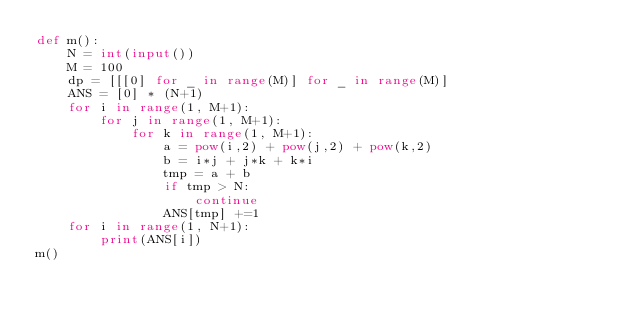Convert code to text. <code><loc_0><loc_0><loc_500><loc_500><_Python_>def m():
    N = int(input())
    M = 100
    dp = [[[0] for _ in range(M)] for _ in range(M)]
    ANS = [0] * (N+1)
    for i in range(1, M+1):
        for j in range(1, M+1):
            for k in range(1, M+1):
                a = pow(i,2) + pow(j,2) + pow(k,2)
                b = i*j + j*k + k*i
                tmp = a + b
                if tmp > N:
                    continue
                ANS[tmp] +=1
    for i in range(1, N+1):
        print(ANS[i])
m()</code> 